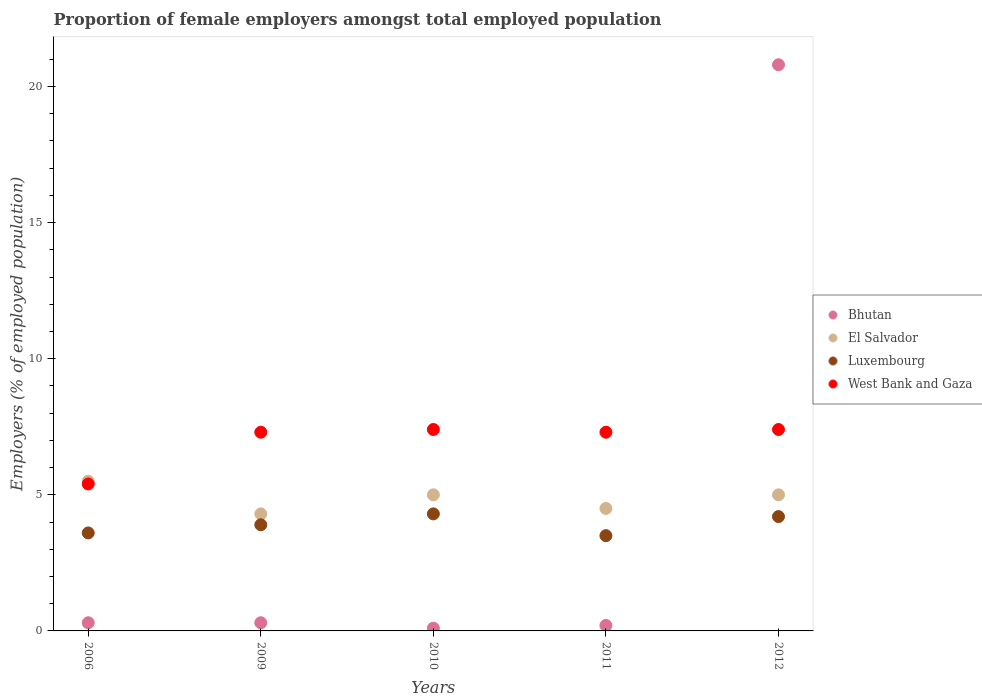How many different coloured dotlines are there?
Provide a succinct answer. 4. Is the number of dotlines equal to the number of legend labels?
Provide a short and direct response. Yes. Across all years, what is the maximum proportion of female employers in Bhutan?
Provide a succinct answer. 20.8. Across all years, what is the minimum proportion of female employers in West Bank and Gaza?
Your answer should be very brief. 5.4. In which year was the proportion of female employers in El Salvador maximum?
Your response must be concise. 2006. What is the total proportion of female employers in El Salvador in the graph?
Your response must be concise. 24.3. What is the difference between the proportion of female employers in Luxembourg in 2010 and that in 2012?
Provide a succinct answer. 0.1. What is the difference between the proportion of female employers in El Salvador in 2006 and the proportion of female employers in West Bank and Gaza in 2011?
Make the answer very short. -1.8. In the year 2009, what is the difference between the proportion of female employers in Bhutan and proportion of female employers in Luxembourg?
Keep it short and to the point. -3.6. What is the ratio of the proportion of female employers in Bhutan in 2011 to that in 2012?
Offer a very short reply. 0.01. Is the proportion of female employers in West Bank and Gaza in 2010 less than that in 2012?
Give a very brief answer. No. What is the difference between the highest and the second highest proportion of female employers in El Salvador?
Your answer should be very brief. 0.5. What is the difference between the highest and the lowest proportion of female employers in West Bank and Gaza?
Your answer should be compact. 2. In how many years, is the proportion of female employers in Luxembourg greater than the average proportion of female employers in Luxembourg taken over all years?
Provide a succinct answer. 3. Is it the case that in every year, the sum of the proportion of female employers in Bhutan and proportion of female employers in West Bank and Gaza  is greater than the sum of proportion of female employers in Luxembourg and proportion of female employers in El Salvador?
Provide a succinct answer. No. Is it the case that in every year, the sum of the proportion of female employers in El Salvador and proportion of female employers in Bhutan  is greater than the proportion of female employers in Luxembourg?
Provide a short and direct response. Yes. How many dotlines are there?
Provide a short and direct response. 4. How many years are there in the graph?
Your answer should be compact. 5. Are the values on the major ticks of Y-axis written in scientific E-notation?
Offer a very short reply. No. Does the graph contain any zero values?
Your answer should be very brief. No. Where does the legend appear in the graph?
Your response must be concise. Center right. How are the legend labels stacked?
Ensure brevity in your answer.  Vertical. What is the title of the graph?
Ensure brevity in your answer.  Proportion of female employers amongst total employed population. What is the label or title of the X-axis?
Keep it short and to the point. Years. What is the label or title of the Y-axis?
Your response must be concise. Employers (% of employed population). What is the Employers (% of employed population) of Bhutan in 2006?
Offer a terse response. 0.3. What is the Employers (% of employed population) in Luxembourg in 2006?
Offer a very short reply. 3.6. What is the Employers (% of employed population) in West Bank and Gaza in 2006?
Keep it short and to the point. 5.4. What is the Employers (% of employed population) of Bhutan in 2009?
Offer a terse response. 0.3. What is the Employers (% of employed population) of El Salvador in 2009?
Make the answer very short. 4.3. What is the Employers (% of employed population) of Luxembourg in 2009?
Keep it short and to the point. 3.9. What is the Employers (% of employed population) of West Bank and Gaza in 2009?
Give a very brief answer. 7.3. What is the Employers (% of employed population) of Bhutan in 2010?
Your answer should be compact. 0.1. What is the Employers (% of employed population) in El Salvador in 2010?
Offer a terse response. 5. What is the Employers (% of employed population) in Luxembourg in 2010?
Give a very brief answer. 4.3. What is the Employers (% of employed population) in West Bank and Gaza in 2010?
Offer a terse response. 7.4. What is the Employers (% of employed population) of Bhutan in 2011?
Give a very brief answer. 0.2. What is the Employers (% of employed population) in El Salvador in 2011?
Keep it short and to the point. 4.5. What is the Employers (% of employed population) of West Bank and Gaza in 2011?
Provide a short and direct response. 7.3. What is the Employers (% of employed population) of Bhutan in 2012?
Offer a terse response. 20.8. What is the Employers (% of employed population) of Luxembourg in 2012?
Your answer should be compact. 4.2. What is the Employers (% of employed population) in West Bank and Gaza in 2012?
Provide a short and direct response. 7.4. Across all years, what is the maximum Employers (% of employed population) in Bhutan?
Ensure brevity in your answer.  20.8. Across all years, what is the maximum Employers (% of employed population) in Luxembourg?
Your answer should be compact. 4.3. Across all years, what is the maximum Employers (% of employed population) in West Bank and Gaza?
Your answer should be very brief. 7.4. Across all years, what is the minimum Employers (% of employed population) of Bhutan?
Your answer should be compact. 0.1. Across all years, what is the minimum Employers (% of employed population) of El Salvador?
Your answer should be very brief. 4.3. Across all years, what is the minimum Employers (% of employed population) of West Bank and Gaza?
Provide a succinct answer. 5.4. What is the total Employers (% of employed population) of Bhutan in the graph?
Provide a short and direct response. 21.7. What is the total Employers (% of employed population) in El Salvador in the graph?
Your answer should be very brief. 24.3. What is the total Employers (% of employed population) in West Bank and Gaza in the graph?
Keep it short and to the point. 34.8. What is the difference between the Employers (% of employed population) of Bhutan in 2006 and that in 2009?
Keep it short and to the point. 0. What is the difference between the Employers (% of employed population) of El Salvador in 2006 and that in 2009?
Provide a short and direct response. 1.2. What is the difference between the Employers (% of employed population) in Luxembourg in 2006 and that in 2009?
Ensure brevity in your answer.  -0.3. What is the difference between the Employers (% of employed population) in West Bank and Gaza in 2006 and that in 2011?
Provide a short and direct response. -1.9. What is the difference between the Employers (% of employed population) of Bhutan in 2006 and that in 2012?
Provide a succinct answer. -20.5. What is the difference between the Employers (% of employed population) in West Bank and Gaza in 2006 and that in 2012?
Offer a very short reply. -2. What is the difference between the Employers (% of employed population) in El Salvador in 2009 and that in 2010?
Keep it short and to the point. -0.7. What is the difference between the Employers (% of employed population) of Luxembourg in 2009 and that in 2010?
Your answer should be very brief. -0.4. What is the difference between the Employers (% of employed population) of Bhutan in 2009 and that in 2011?
Your answer should be very brief. 0.1. What is the difference between the Employers (% of employed population) in El Salvador in 2009 and that in 2011?
Make the answer very short. -0.2. What is the difference between the Employers (% of employed population) in Luxembourg in 2009 and that in 2011?
Your response must be concise. 0.4. What is the difference between the Employers (% of employed population) in Bhutan in 2009 and that in 2012?
Provide a succinct answer. -20.5. What is the difference between the Employers (% of employed population) in El Salvador in 2009 and that in 2012?
Offer a terse response. -0.7. What is the difference between the Employers (% of employed population) of Luxembourg in 2009 and that in 2012?
Keep it short and to the point. -0.3. What is the difference between the Employers (% of employed population) in Luxembourg in 2010 and that in 2011?
Give a very brief answer. 0.8. What is the difference between the Employers (% of employed population) in West Bank and Gaza in 2010 and that in 2011?
Offer a terse response. 0.1. What is the difference between the Employers (% of employed population) in Bhutan in 2010 and that in 2012?
Offer a very short reply. -20.7. What is the difference between the Employers (% of employed population) of El Salvador in 2010 and that in 2012?
Keep it short and to the point. 0. What is the difference between the Employers (% of employed population) in West Bank and Gaza in 2010 and that in 2012?
Keep it short and to the point. 0. What is the difference between the Employers (% of employed population) of Bhutan in 2011 and that in 2012?
Your response must be concise. -20.6. What is the difference between the Employers (% of employed population) in El Salvador in 2011 and that in 2012?
Your answer should be compact. -0.5. What is the difference between the Employers (% of employed population) in Luxembourg in 2011 and that in 2012?
Provide a short and direct response. -0.7. What is the difference between the Employers (% of employed population) in Luxembourg in 2006 and the Employers (% of employed population) in West Bank and Gaza in 2009?
Offer a very short reply. -3.7. What is the difference between the Employers (% of employed population) of Bhutan in 2006 and the Employers (% of employed population) of Luxembourg in 2010?
Your answer should be compact. -4. What is the difference between the Employers (% of employed population) in Luxembourg in 2006 and the Employers (% of employed population) in West Bank and Gaza in 2010?
Your answer should be very brief. -3.8. What is the difference between the Employers (% of employed population) of Bhutan in 2006 and the Employers (% of employed population) of El Salvador in 2011?
Your response must be concise. -4.2. What is the difference between the Employers (% of employed population) in El Salvador in 2006 and the Employers (% of employed population) in Luxembourg in 2011?
Keep it short and to the point. 2. What is the difference between the Employers (% of employed population) of Luxembourg in 2006 and the Employers (% of employed population) of West Bank and Gaza in 2011?
Make the answer very short. -3.7. What is the difference between the Employers (% of employed population) in Bhutan in 2006 and the Employers (% of employed population) in El Salvador in 2012?
Your answer should be very brief. -4.7. What is the difference between the Employers (% of employed population) of Bhutan in 2006 and the Employers (% of employed population) of Luxembourg in 2012?
Your response must be concise. -3.9. What is the difference between the Employers (% of employed population) in El Salvador in 2006 and the Employers (% of employed population) in Luxembourg in 2012?
Make the answer very short. 1.3. What is the difference between the Employers (% of employed population) in El Salvador in 2006 and the Employers (% of employed population) in West Bank and Gaza in 2012?
Provide a succinct answer. -1.9. What is the difference between the Employers (% of employed population) of Luxembourg in 2006 and the Employers (% of employed population) of West Bank and Gaza in 2012?
Offer a very short reply. -3.8. What is the difference between the Employers (% of employed population) of Bhutan in 2009 and the Employers (% of employed population) of El Salvador in 2010?
Your answer should be compact. -4.7. What is the difference between the Employers (% of employed population) of El Salvador in 2009 and the Employers (% of employed population) of Luxembourg in 2010?
Your answer should be compact. 0. What is the difference between the Employers (% of employed population) in El Salvador in 2009 and the Employers (% of employed population) in West Bank and Gaza in 2010?
Ensure brevity in your answer.  -3.1. What is the difference between the Employers (% of employed population) of Luxembourg in 2009 and the Employers (% of employed population) of West Bank and Gaza in 2010?
Provide a succinct answer. -3.5. What is the difference between the Employers (% of employed population) of Bhutan in 2009 and the Employers (% of employed population) of El Salvador in 2011?
Offer a very short reply. -4.2. What is the difference between the Employers (% of employed population) of Bhutan in 2009 and the Employers (% of employed population) of Luxembourg in 2011?
Provide a short and direct response. -3.2. What is the difference between the Employers (% of employed population) of El Salvador in 2009 and the Employers (% of employed population) of West Bank and Gaza in 2011?
Ensure brevity in your answer.  -3. What is the difference between the Employers (% of employed population) in Bhutan in 2009 and the Employers (% of employed population) in El Salvador in 2012?
Make the answer very short. -4.7. What is the difference between the Employers (% of employed population) of Bhutan in 2009 and the Employers (% of employed population) of Luxembourg in 2012?
Provide a short and direct response. -3.9. What is the difference between the Employers (% of employed population) of El Salvador in 2009 and the Employers (% of employed population) of Luxembourg in 2012?
Offer a terse response. 0.1. What is the difference between the Employers (% of employed population) in Luxembourg in 2009 and the Employers (% of employed population) in West Bank and Gaza in 2012?
Offer a terse response. -3.5. What is the difference between the Employers (% of employed population) of Bhutan in 2010 and the Employers (% of employed population) of El Salvador in 2011?
Offer a terse response. -4.4. What is the difference between the Employers (% of employed population) of Bhutan in 2010 and the Employers (% of employed population) of West Bank and Gaza in 2011?
Give a very brief answer. -7.2. What is the difference between the Employers (% of employed population) in El Salvador in 2010 and the Employers (% of employed population) in Luxembourg in 2011?
Give a very brief answer. 1.5. What is the difference between the Employers (% of employed population) in El Salvador in 2010 and the Employers (% of employed population) in West Bank and Gaza in 2011?
Your answer should be very brief. -2.3. What is the difference between the Employers (% of employed population) of Bhutan in 2010 and the Employers (% of employed population) of Luxembourg in 2012?
Make the answer very short. -4.1. What is the difference between the Employers (% of employed population) in Bhutan in 2010 and the Employers (% of employed population) in West Bank and Gaza in 2012?
Offer a terse response. -7.3. What is the difference between the Employers (% of employed population) of El Salvador in 2010 and the Employers (% of employed population) of Luxembourg in 2012?
Keep it short and to the point. 0.8. What is the difference between the Employers (% of employed population) of Luxembourg in 2010 and the Employers (% of employed population) of West Bank and Gaza in 2012?
Your response must be concise. -3.1. What is the difference between the Employers (% of employed population) of Bhutan in 2011 and the Employers (% of employed population) of El Salvador in 2012?
Provide a succinct answer. -4.8. What is the difference between the Employers (% of employed population) in Bhutan in 2011 and the Employers (% of employed population) in West Bank and Gaza in 2012?
Offer a very short reply. -7.2. What is the difference between the Employers (% of employed population) in El Salvador in 2011 and the Employers (% of employed population) in Luxembourg in 2012?
Offer a terse response. 0.3. What is the difference between the Employers (% of employed population) of El Salvador in 2011 and the Employers (% of employed population) of West Bank and Gaza in 2012?
Provide a short and direct response. -2.9. What is the average Employers (% of employed population) in Bhutan per year?
Make the answer very short. 4.34. What is the average Employers (% of employed population) of El Salvador per year?
Ensure brevity in your answer.  4.86. What is the average Employers (% of employed population) in West Bank and Gaza per year?
Provide a short and direct response. 6.96. In the year 2006, what is the difference between the Employers (% of employed population) in Bhutan and Employers (% of employed population) in El Salvador?
Offer a terse response. -5.2. In the year 2006, what is the difference between the Employers (% of employed population) of Bhutan and Employers (% of employed population) of West Bank and Gaza?
Ensure brevity in your answer.  -5.1. In the year 2006, what is the difference between the Employers (% of employed population) of El Salvador and Employers (% of employed population) of Luxembourg?
Provide a short and direct response. 1.9. In the year 2006, what is the difference between the Employers (% of employed population) in El Salvador and Employers (% of employed population) in West Bank and Gaza?
Your response must be concise. 0.1. In the year 2006, what is the difference between the Employers (% of employed population) of Luxembourg and Employers (% of employed population) of West Bank and Gaza?
Provide a short and direct response. -1.8. In the year 2010, what is the difference between the Employers (% of employed population) in Bhutan and Employers (% of employed population) in West Bank and Gaza?
Offer a very short reply. -7.3. In the year 2010, what is the difference between the Employers (% of employed population) in El Salvador and Employers (% of employed population) in West Bank and Gaza?
Give a very brief answer. -2.4. In the year 2011, what is the difference between the Employers (% of employed population) in Bhutan and Employers (% of employed population) in El Salvador?
Provide a short and direct response. -4.3. In the year 2011, what is the difference between the Employers (% of employed population) of Luxembourg and Employers (% of employed population) of West Bank and Gaza?
Offer a terse response. -3.8. In the year 2012, what is the difference between the Employers (% of employed population) of Bhutan and Employers (% of employed population) of Luxembourg?
Keep it short and to the point. 16.6. In the year 2012, what is the difference between the Employers (% of employed population) in Bhutan and Employers (% of employed population) in West Bank and Gaza?
Ensure brevity in your answer.  13.4. In the year 2012, what is the difference between the Employers (% of employed population) in El Salvador and Employers (% of employed population) in Luxembourg?
Your answer should be compact. 0.8. In the year 2012, what is the difference between the Employers (% of employed population) of El Salvador and Employers (% of employed population) of West Bank and Gaza?
Offer a terse response. -2.4. In the year 2012, what is the difference between the Employers (% of employed population) of Luxembourg and Employers (% of employed population) of West Bank and Gaza?
Your answer should be compact. -3.2. What is the ratio of the Employers (% of employed population) of El Salvador in 2006 to that in 2009?
Your answer should be very brief. 1.28. What is the ratio of the Employers (% of employed population) in Luxembourg in 2006 to that in 2009?
Offer a terse response. 0.92. What is the ratio of the Employers (% of employed population) in West Bank and Gaza in 2006 to that in 2009?
Provide a short and direct response. 0.74. What is the ratio of the Employers (% of employed population) of Luxembourg in 2006 to that in 2010?
Give a very brief answer. 0.84. What is the ratio of the Employers (% of employed population) of West Bank and Gaza in 2006 to that in 2010?
Offer a terse response. 0.73. What is the ratio of the Employers (% of employed population) in El Salvador in 2006 to that in 2011?
Provide a succinct answer. 1.22. What is the ratio of the Employers (% of employed population) of Luxembourg in 2006 to that in 2011?
Offer a terse response. 1.03. What is the ratio of the Employers (% of employed population) of West Bank and Gaza in 2006 to that in 2011?
Provide a short and direct response. 0.74. What is the ratio of the Employers (% of employed population) of Bhutan in 2006 to that in 2012?
Keep it short and to the point. 0.01. What is the ratio of the Employers (% of employed population) of El Salvador in 2006 to that in 2012?
Your response must be concise. 1.1. What is the ratio of the Employers (% of employed population) in Luxembourg in 2006 to that in 2012?
Your answer should be compact. 0.86. What is the ratio of the Employers (% of employed population) of West Bank and Gaza in 2006 to that in 2012?
Your answer should be very brief. 0.73. What is the ratio of the Employers (% of employed population) in Bhutan in 2009 to that in 2010?
Offer a very short reply. 3. What is the ratio of the Employers (% of employed population) in El Salvador in 2009 to that in 2010?
Provide a succinct answer. 0.86. What is the ratio of the Employers (% of employed population) of Luxembourg in 2009 to that in 2010?
Provide a short and direct response. 0.91. What is the ratio of the Employers (% of employed population) of West Bank and Gaza in 2009 to that in 2010?
Offer a terse response. 0.99. What is the ratio of the Employers (% of employed population) of El Salvador in 2009 to that in 2011?
Make the answer very short. 0.96. What is the ratio of the Employers (% of employed population) in Luxembourg in 2009 to that in 2011?
Provide a succinct answer. 1.11. What is the ratio of the Employers (% of employed population) of West Bank and Gaza in 2009 to that in 2011?
Your response must be concise. 1. What is the ratio of the Employers (% of employed population) of Bhutan in 2009 to that in 2012?
Your answer should be very brief. 0.01. What is the ratio of the Employers (% of employed population) of El Salvador in 2009 to that in 2012?
Your response must be concise. 0.86. What is the ratio of the Employers (% of employed population) in West Bank and Gaza in 2009 to that in 2012?
Offer a very short reply. 0.99. What is the ratio of the Employers (% of employed population) in Bhutan in 2010 to that in 2011?
Provide a succinct answer. 0.5. What is the ratio of the Employers (% of employed population) of El Salvador in 2010 to that in 2011?
Offer a terse response. 1.11. What is the ratio of the Employers (% of employed population) in Luxembourg in 2010 to that in 2011?
Your answer should be very brief. 1.23. What is the ratio of the Employers (% of employed population) of West Bank and Gaza in 2010 to that in 2011?
Your response must be concise. 1.01. What is the ratio of the Employers (% of employed population) in Bhutan in 2010 to that in 2012?
Your answer should be compact. 0. What is the ratio of the Employers (% of employed population) of Luxembourg in 2010 to that in 2012?
Your answer should be compact. 1.02. What is the ratio of the Employers (% of employed population) of Bhutan in 2011 to that in 2012?
Your answer should be very brief. 0.01. What is the ratio of the Employers (% of employed population) in West Bank and Gaza in 2011 to that in 2012?
Provide a short and direct response. 0.99. What is the difference between the highest and the second highest Employers (% of employed population) in Bhutan?
Keep it short and to the point. 20.5. What is the difference between the highest and the lowest Employers (% of employed population) in Bhutan?
Provide a succinct answer. 20.7. 